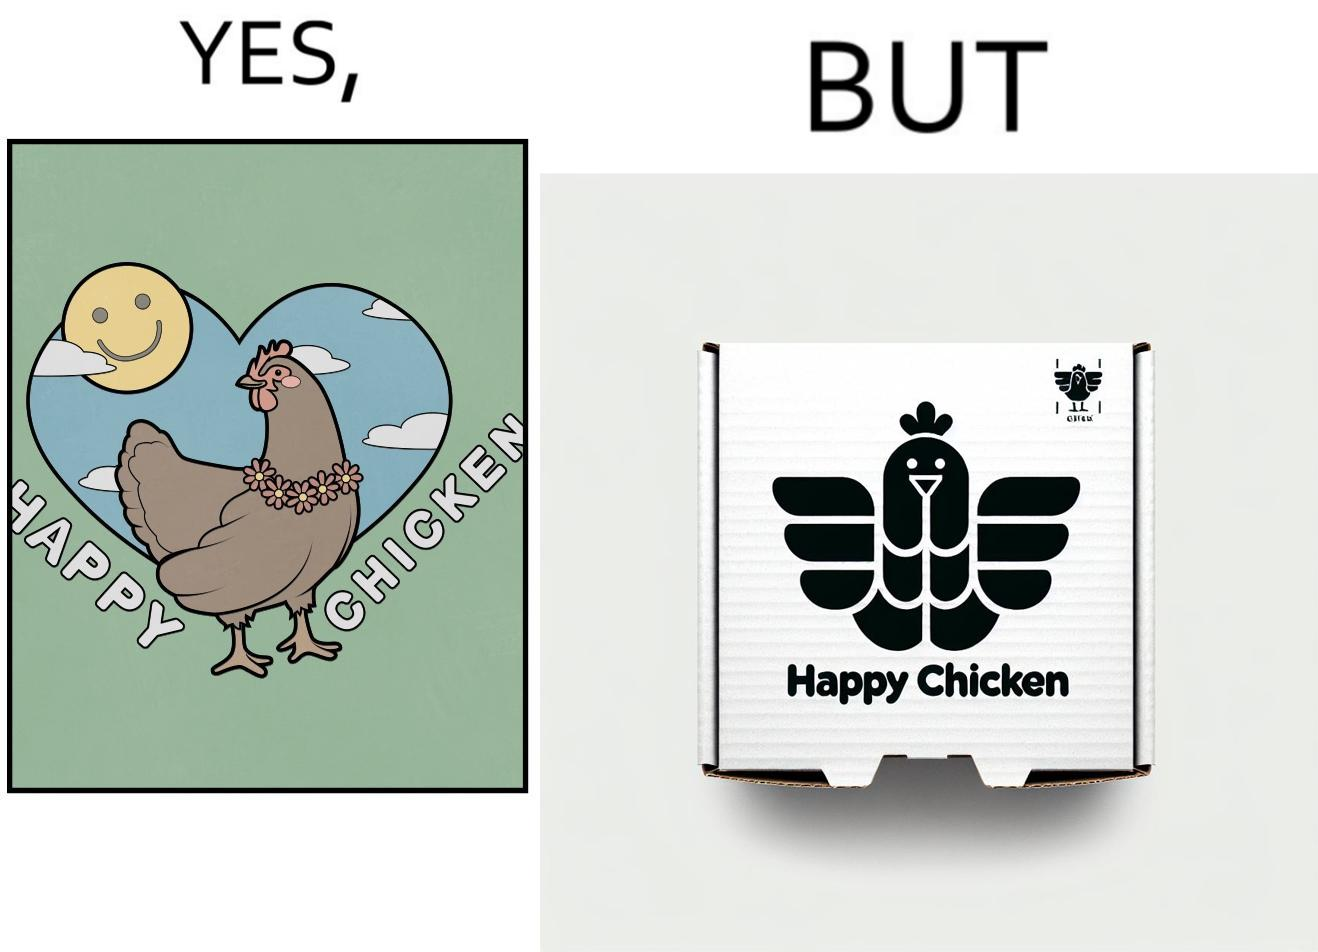Describe the satirical element in this image. The image is ironic, because in the left image as in the logo it shows happy chicken but in the right image the chicken pieces are shown packed in boxes 